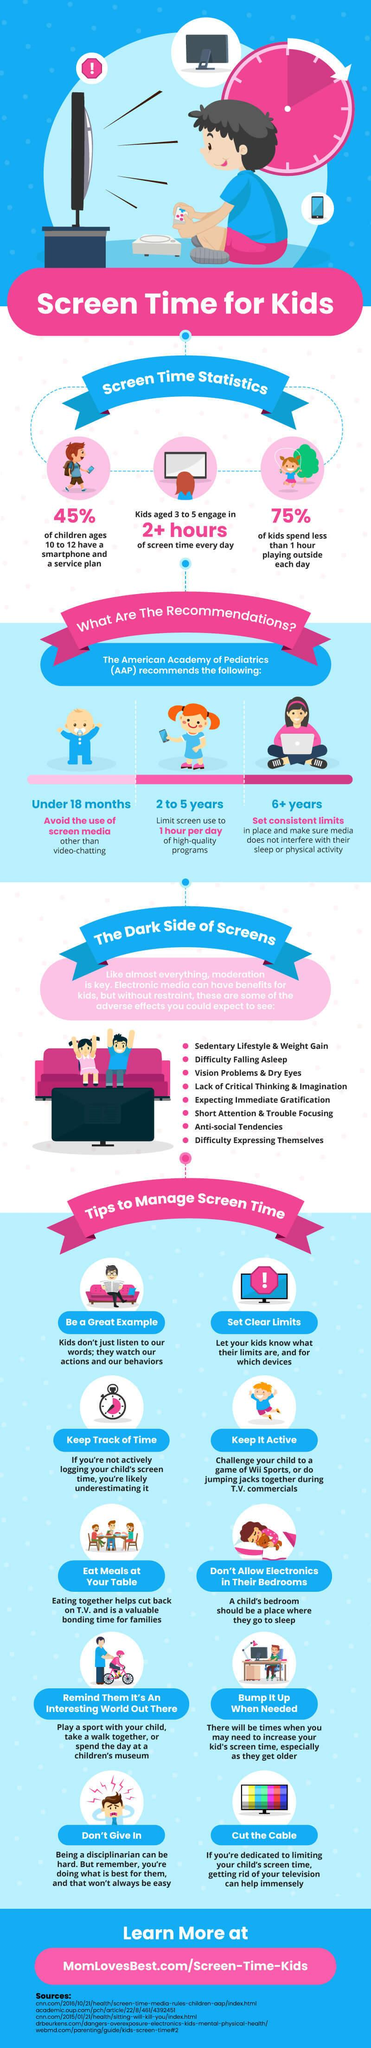Identify some key points in this picture. Excessive screen time has been reported to cause short attention and difficulty focusing, which is listed as a side effect sixth in the list. Research has shown that children in the age group of 3 to 5 who engage in more than 2 hours of screen time daily are more likely to experience negative effects on their health and development. Excessive screen time has been reported to cause difficulty falling asleep as the second side effect. The American Academy of Pediatrics recommends that children aged 2 to 5 years old should not exceed one hour of screen time per day. Use of screen media should be avoided for individuals under the age of 18 months. 